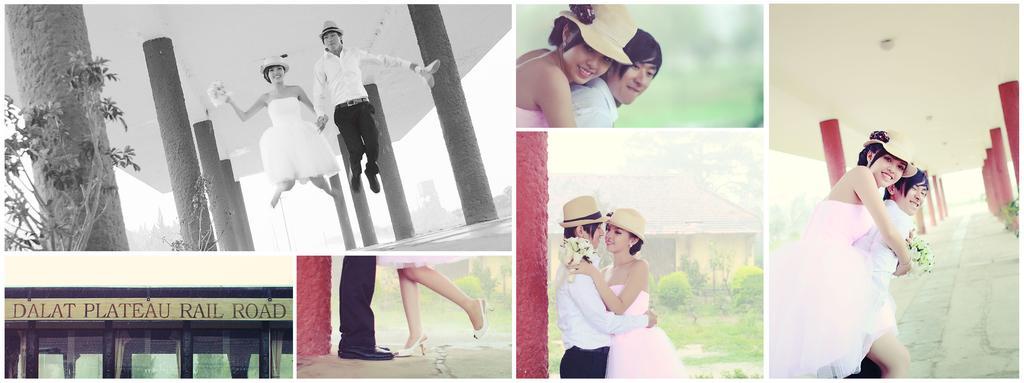How would you summarize this image in a sentence or two? In this image we can see this picture is in black and white where we can see a man and woman are in the air and we can see pillars and plants. In these pictures we can see a woman wearing pink dress and a man wearing white shirt and hat are standing. In this picture we can see the person's leg and in this picture we can see the board and glass doors. 